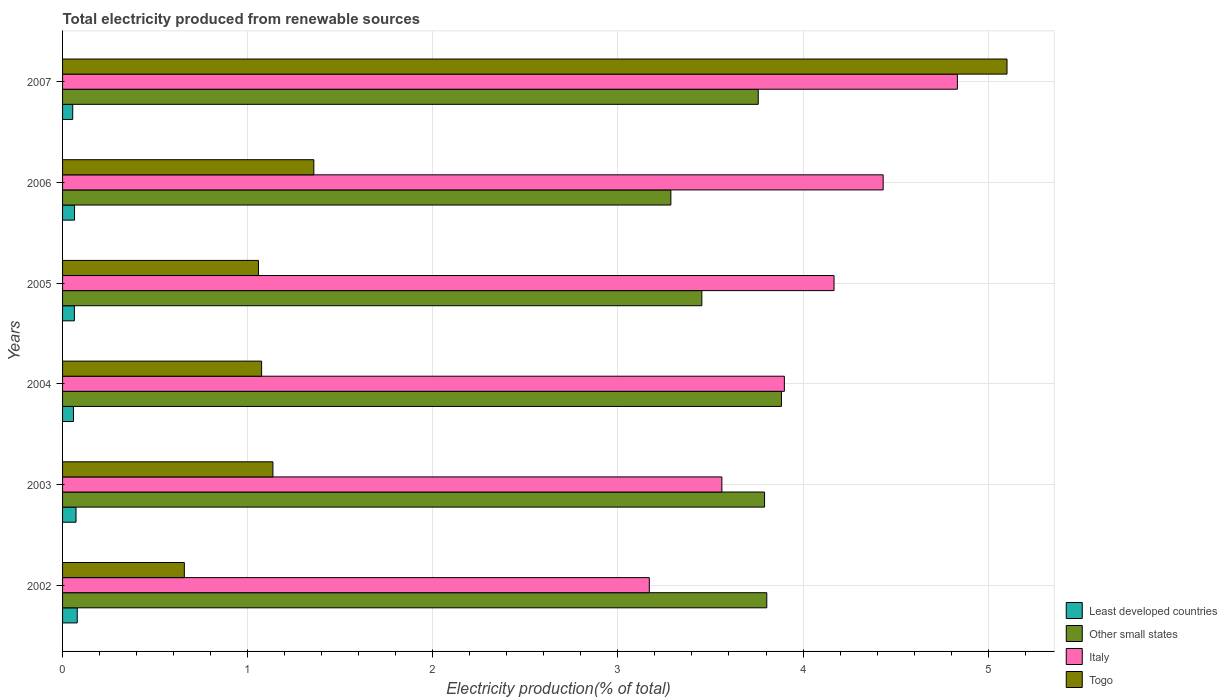How many different coloured bars are there?
Your answer should be very brief. 4. How many groups of bars are there?
Make the answer very short. 6. Are the number of bars per tick equal to the number of legend labels?
Provide a short and direct response. Yes. Are the number of bars on each tick of the Y-axis equal?
Make the answer very short. Yes. How many bars are there on the 1st tick from the bottom?
Keep it short and to the point. 4. What is the label of the 2nd group of bars from the top?
Provide a succinct answer. 2006. What is the total electricity produced in Togo in 2003?
Provide a short and direct response. 1.14. Across all years, what is the maximum total electricity produced in Togo?
Your response must be concise. 5.1. Across all years, what is the minimum total electricity produced in Other small states?
Your answer should be compact. 3.29. In which year was the total electricity produced in Italy maximum?
Make the answer very short. 2007. In which year was the total electricity produced in Togo minimum?
Give a very brief answer. 2002. What is the total total electricity produced in Least developed countries in the graph?
Offer a terse response. 0.39. What is the difference between the total electricity produced in Italy in 2003 and that in 2005?
Provide a short and direct response. -0.61. What is the difference between the total electricity produced in Least developed countries in 2007 and the total electricity produced in Other small states in 2003?
Your response must be concise. -3.74. What is the average total electricity produced in Togo per year?
Keep it short and to the point. 1.73. In the year 2002, what is the difference between the total electricity produced in Italy and total electricity produced in Togo?
Provide a succinct answer. 2.51. In how many years, is the total electricity produced in Least developed countries greater than 1.8 %?
Offer a very short reply. 0. What is the ratio of the total electricity produced in Togo in 2006 to that in 2007?
Offer a terse response. 0.27. Is the total electricity produced in Togo in 2002 less than that in 2007?
Offer a very short reply. Yes. What is the difference between the highest and the second highest total electricity produced in Italy?
Offer a terse response. 0.4. What is the difference between the highest and the lowest total electricity produced in Other small states?
Offer a terse response. 0.6. Is it the case that in every year, the sum of the total electricity produced in Other small states and total electricity produced in Italy is greater than the sum of total electricity produced in Least developed countries and total electricity produced in Togo?
Offer a very short reply. Yes. What does the 4th bar from the top in 2005 represents?
Offer a very short reply. Least developed countries. What does the 2nd bar from the bottom in 2004 represents?
Make the answer very short. Other small states. Is it the case that in every year, the sum of the total electricity produced in Togo and total electricity produced in Italy is greater than the total electricity produced in Least developed countries?
Offer a terse response. Yes. How many bars are there?
Provide a short and direct response. 24. Are all the bars in the graph horizontal?
Your response must be concise. Yes. How many years are there in the graph?
Provide a succinct answer. 6. Are the values on the major ticks of X-axis written in scientific E-notation?
Your answer should be very brief. No. Does the graph contain grids?
Keep it short and to the point. Yes. How many legend labels are there?
Offer a terse response. 4. What is the title of the graph?
Keep it short and to the point. Total electricity produced from renewable sources. Does "Malawi" appear as one of the legend labels in the graph?
Your answer should be compact. No. What is the Electricity production(% of total) in Least developed countries in 2002?
Provide a succinct answer. 0.08. What is the Electricity production(% of total) of Other small states in 2002?
Offer a very short reply. 3.8. What is the Electricity production(% of total) of Italy in 2002?
Provide a short and direct response. 3.17. What is the Electricity production(% of total) of Togo in 2002?
Give a very brief answer. 0.66. What is the Electricity production(% of total) of Least developed countries in 2003?
Offer a terse response. 0.07. What is the Electricity production(% of total) in Other small states in 2003?
Your response must be concise. 3.79. What is the Electricity production(% of total) in Italy in 2003?
Offer a terse response. 3.56. What is the Electricity production(% of total) of Togo in 2003?
Provide a succinct answer. 1.14. What is the Electricity production(% of total) of Least developed countries in 2004?
Your answer should be compact. 0.06. What is the Electricity production(% of total) of Other small states in 2004?
Provide a succinct answer. 3.88. What is the Electricity production(% of total) of Italy in 2004?
Your answer should be very brief. 3.9. What is the Electricity production(% of total) of Togo in 2004?
Provide a succinct answer. 1.08. What is the Electricity production(% of total) of Least developed countries in 2005?
Your answer should be very brief. 0.06. What is the Electricity production(% of total) of Other small states in 2005?
Ensure brevity in your answer.  3.45. What is the Electricity production(% of total) in Italy in 2005?
Provide a succinct answer. 4.17. What is the Electricity production(% of total) in Togo in 2005?
Your response must be concise. 1.06. What is the Electricity production(% of total) in Least developed countries in 2006?
Offer a terse response. 0.06. What is the Electricity production(% of total) of Other small states in 2006?
Keep it short and to the point. 3.29. What is the Electricity production(% of total) of Italy in 2006?
Offer a terse response. 4.43. What is the Electricity production(% of total) in Togo in 2006?
Provide a succinct answer. 1.36. What is the Electricity production(% of total) in Least developed countries in 2007?
Keep it short and to the point. 0.05. What is the Electricity production(% of total) in Other small states in 2007?
Make the answer very short. 3.76. What is the Electricity production(% of total) in Italy in 2007?
Your response must be concise. 4.83. What is the Electricity production(% of total) in Togo in 2007?
Your response must be concise. 5.1. Across all years, what is the maximum Electricity production(% of total) in Least developed countries?
Ensure brevity in your answer.  0.08. Across all years, what is the maximum Electricity production(% of total) of Other small states?
Offer a terse response. 3.88. Across all years, what is the maximum Electricity production(% of total) in Italy?
Offer a terse response. 4.83. Across all years, what is the maximum Electricity production(% of total) in Togo?
Provide a short and direct response. 5.1. Across all years, what is the minimum Electricity production(% of total) of Least developed countries?
Ensure brevity in your answer.  0.05. Across all years, what is the minimum Electricity production(% of total) in Other small states?
Your answer should be compact. 3.29. Across all years, what is the minimum Electricity production(% of total) in Italy?
Your response must be concise. 3.17. Across all years, what is the minimum Electricity production(% of total) of Togo?
Keep it short and to the point. 0.66. What is the total Electricity production(% of total) in Least developed countries in the graph?
Offer a very short reply. 0.39. What is the total Electricity production(% of total) in Other small states in the graph?
Give a very brief answer. 21.98. What is the total Electricity production(% of total) in Italy in the graph?
Your answer should be very brief. 24.07. What is the total Electricity production(% of total) in Togo in the graph?
Keep it short and to the point. 10.39. What is the difference between the Electricity production(% of total) in Least developed countries in 2002 and that in 2003?
Give a very brief answer. 0.01. What is the difference between the Electricity production(% of total) of Other small states in 2002 and that in 2003?
Offer a very short reply. 0.01. What is the difference between the Electricity production(% of total) in Italy in 2002 and that in 2003?
Offer a very short reply. -0.39. What is the difference between the Electricity production(% of total) of Togo in 2002 and that in 2003?
Ensure brevity in your answer.  -0.48. What is the difference between the Electricity production(% of total) in Least developed countries in 2002 and that in 2004?
Make the answer very short. 0.02. What is the difference between the Electricity production(% of total) of Other small states in 2002 and that in 2004?
Provide a short and direct response. -0.08. What is the difference between the Electricity production(% of total) in Italy in 2002 and that in 2004?
Provide a short and direct response. -0.73. What is the difference between the Electricity production(% of total) of Togo in 2002 and that in 2004?
Give a very brief answer. -0.42. What is the difference between the Electricity production(% of total) of Least developed countries in 2002 and that in 2005?
Keep it short and to the point. 0.02. What is the difference between the Electricity production(% of total) of Other small states in 2002 and that in 2005?
Ensure brevity in your answer.  0.35. What is the difference between the Electricity production(% of total) in Italy in 2002 and that in 2005?
Provide a short and direct response. -1. What is the difference between the Electricity production(% of total) of Togo in 2002 and that in 2005?
Your answer should be very brief. -0.4. What is the difference between the Electricity production(% of total) of Least developed countries in 2002 and that in 2006?
Offer a very short reply. 0.01. What is the difference between the Electricity production(% of total) in Other small states in 2002 and that in 2006?
Provide a short and direct response. 0.52. What is the difference between the Electricity production(% of total) of Italy in 2002 and that in 2006?
Make the answer very short. -1.26. What is the difference between the Electricity production(% of total) in Togo in 2002 and that in 2006?
Provide a succinct answer. -0.7. What is the difference between the Electricity production(% of total) in Least developed countries in 2002 and that in 2007?
Your answer should be very brief. 0.02. What is the difference between the Electricity production(% of total) in Other small states in 2002 and that in 2007?
Provide a succinct answer. 0.05. What is the difference between the Electricity production(% of total) in Italy in 2002 and that in 2007?
Provide a succinct answer. -1.66. What is the difference between the Electricity production(% of total) in Togo in 2002 and that in 2007?
Keep it short and to the point. -4.44. What is the difference between the Electricity production(% of total) in Least developed countries in 2003 and that in 2004?
Ensure brevity in your answer.  0.01. What is the difference between the Electricity production(% of total) in Other small states in 2003 and that in 2004?
Provide a short and direct response. -0.09. What is the difference between the Electricity production(% of total) of Italy in 2003 and that in 2004?
Keep it short and to the point. -0.34. What is the difference between the Electricity production(% of total) in Togo in 2003 and that in 2004?
Provide a succinct answer. 0.06. What is the difference between the Electricity production(% of total) of Least developed countries in 2003 and that in 2005?
Your answer should be compact. 0.01. What is the difference between the Electricity production(% of total) in Other small states in 2003 and that in 2005?
Keep it short and to the point. 0.34. What is the difference between the Electricity production(% of total) in Italy in 2003 and that in 2005?
Give a very brief answer. -0.61. What is the difference between the Electricity production(% of total) in Togo in 2003 and that in 2005?
Keep it short and to the point. 0.08. What is the difference between the Electricity production(% of total) of Least developed countries in 2003 and that in 2006?
Provide a succinct answer. 0.01. What is the difference between the Electricity production(% of total) of Other small states in 2003 and that in 2006?
Your response must be concise. 0.51. What is the difference between the Electricity production(% of total) of Italy in 2003 and that in 2006?
Your response must be concise. -0.87. What is the difference between the Electricity production(% of total) in Togo in 2003 and that in 2006?
Your answer should be very brief. -0.22. What is the difference between the Electricity production(% of total) in Least developed countries in 2003 and that in 2007?
Offer a very short reply. 0.02. What is the difference between the Electricity production(% of total) of Other small states in 2003 and that in 2007?
Your answer should be compact. 0.03. What is the difference between the Electricity production(% of total) of Italy in 2003 and that in 2007?
Your answer should be very brief. -1.27. What is the difference between the Electricity production(% of total) of Togo in 2003 and that in 2007?
Your answer should be compact. -3.97. What is the difference between the Electricity production(% of total) of Least developed countries in 2004 and that in 2005?
Keep it short and to the point. -0. What is the difference between the Electricity production(% of total) of Other small states in 2004 and that in 2005?
Keep it short and to the point. 0.43. What is the difference between the Electricity production(% of total) in Italy in 2004 and that in 2005?
Your answer should be compact. -0.27. What is the difference between the Electricity production(% of total) of Togo in 2004 and that in 2005?
Provide a short and direct response. 0.02. What is the difference between the Electricity production(% of total) of Least developed countries in 2004 and that in 2006?
Ensure brevity in your answer.  -0.01. What is the difference between the Electricity production(% of total) in Other small states in 2004 and that in 2006?
Ensure brevity in your answer.  0.6. What is the difference between the Electricity production(% of total) of Italy in 2004 and that in 2006?
Offer a terse response. -0.53. What is the difference between the Electricity production(% of total) of Togo in 2004 and that in 2006?
Your answer should be very brief. -0.28. What is the difference between the Electricity production(% of total) in Least developed countries in 2004 and that in 2007?
Offer a terse response. 0. What is the difference between the Electricity production(% of total) of Other small states in 2004 and that in 2007?
Your answer should be compact. 0.13. What is the difference between the Electricity production(% of total) in Italy in 2004 and that in 2007?
Offer a terse response. -0.93. What is the difference between the Electricity production(% of total) of Togo in 2004 and that in 2007?
Make the answer very short. -4.03. What is the difference between the Electricity production(% of total) of Least developed countries in 2005 and that in 2006?
Provide a short and direct response. -0. What is the difference between the Electricity production(% of total) in Other small states in 2005 and that in 2006?
Keep it short and to the point. 0.17. What is the difference between the Electricity production(% of total) in Italy in 2005 and that in 2006?
Provide a succinct answer. -0.27. What is the difference between the Electricity production(% of total) in Togo in 2005 and that in 2006?
Make the answer very short. -0.3. What is the difference between the Electricity production(% of total) in Least developed countries in 2005 and that in 2007?
Give a very brief answer. 0.01. What is the difference between the Electricity production(% of total) of Other small states in 2005 and that in 2007?
Offer a terse response. -0.3. What is the difference between the Electricity production(% of total) in Italy in 2005 and that in 2007?
Your answer should be compact. -0.67. What is the difference between the Electricity production(% of total) in Togo in 2005 and that in 2007?
Keep it short and to the point. -4.04. What is the difference between the Electricity production(% of total) of Least developed countries in 2006 and that in 2007?
Your answer should be compact. 0.01. What is the difference between the Electricity production(% of total) in Other small states in 2006 and that in 2007?
Offer a terse response. -0.47. What is the difference between the Electricity production(% of total) in Italy in 2006 and that in 2007?
Give a very brief answer. -0.4. What is the difference between the Electricity production(% of total) in Togo in 2006 and that in 2007?
Your answer should be compact. -3.74. What is the difference between the Electricity production(% of total) in Least developed countries in 2002 and the Electricity production(% of total) in Other small states in 2003?
Make the answer very short. -3.71. What is the difference between the Electricity production(% of total) in Least developed countries in 2002 and the Electricity production(% of total) in Italy in 2003?
Provide a succinct answer. -3.48. What is the difference between the Electricity production(% of total) in Least developed countries in 2002 and the Electricity production(% of total) in Togo in 2003?
Make the answer very short. -1.06. What is the difference between the Electricity production(% of total) of Other small states in 2002 and the Electricity production(% of total) of Italy in 2003?
Offer a terse response. 0.24. What is the difference between the Electricity production(% of total) in Other small states in 2002 and the Electricity production(% of total) in Togo in 2003?
Give a very brief answer. 2.67. What is the difference between the Electricity production(% of total) in Italy in 2002 and the Electricity production(% of total) in Togo in 2003?
Your answer should be very brief. 2.03. What is the difference between the Electricity production(% of total) of Least developed countries in 2002 and the Electricity production(% of total) of Other small states in 2004?
Provide a short and direct response. -3.8. What is the difference between the Electricity production(% of total) of Least developed countries in 2002 and the Electricity production(% of total) of Italy in 2004?
Ensure brevity in your answer.  -3.82. What is the difference between the Electricity production(% of total) in Least developed countries in 2002 and the Electricity production(% of total) in Togo in 2004?
Provide a succinct answer. -1. What is the difference between the Electricity production(% of total) in Other small states in 2002 and the Electricity production(% of total) in Italy in 2004?
Provide a short and direct response. -0.1. What is the difference between the Electricity production(% of total) of Other small states in 2002 and the Electricity production(% of total) of Togo in 2004?
Give a very brief answer. 2.73. What is the difference between the Electricity production(% of total) in Italy in 2002 and the Electricity production(% of total) in Togo in 2004?
Provide a short and direct response. 2.09. What is the difference between the Electricity production(% of total) in Least developed countries in 2002 and the Electricity production(% of total) in Other small states in 2005?
Keep it short and to the point. -3.37. What is the difference between the Electricity production(% of total) of Least developed countries in 2002 and the Electricity production(% of total) of Italy in 2005?
Your response must be concise. -4.09. What is the difference between the Electricity production(% of total) in Least developed countries in 2002 and the Electricity production(% of total) in Togo in 2005?
Offer a terse response. -0.98. What is the difference between the Electricity production(% of total) of Other small states in 2002 and the Electricity production(% of total) of Italy in 2005?
Your answer should be very brief. -0.36. What is the difference between the Electricity production(% of total) in Other small states in 2002 and the Electricity production(% of total) in Togo in 2005?
Keep it short and to the point. 2.75. What is the difference between the Electricity production(% of total) in Italy in 2002 and the Electricity production(% of total) in Togo in 2005?
Your answer should be very brief. 2.11. What is the difference between the Electricity production(% of total) in Least developed countries in 2002 and the Electricity production(% of total) in Other small states in 2006?
Keep it short and to the point. -3.21. What is the difference between the Electricity production(% of total) of Least developed countries in 2002 and the Electricity production(% of total) of Italy in 2006?
Your response must be concise. -4.35. What is the difference between the Electricity production(% of total) of Least developed countries in 2002 and the Electricity production(% of total) of Togo in 2006?
Your answer should be very brief. -1.28. What is the difference between the Electricity production(% of total) of Other small states in 2002 and the Electricity production(% of total) of Italy in 2006?
Give a very brief answer. -0.63. What is the difference between the Electricity production(% of total) of Other small states in 2002 and the Electricity production(% of total) of Togo in 2006?
Your response must be concise. 2.45. What is the difference between the Electricity production(% of total) in Italy in 2002 and the Electricity production(% of total) in Togo in 2006?
Give a very brief answer. 1.81. What is the difference between the Electricity production(% of total) in Least developed countries in 2002 and the Electricity production(% of total) in Other small states in 2007?
Your response must be concise. -3.68. What is the difference between the Electricity production(% of total) in Least developed countries in 2002 and the Electricity production(% of total) in Italy in 2007?
Offer a very short reply. -4.75. What is the difference between the Electricity production(% of total) in Least developed countries in 2002 and the Electricity production(% of total) in Togo in 2007?
Offer a very short reply. -5.02. What is the difference between the Electricity production(% of total) in Other small states in 2002 and the Electricity production(% of total) in Italy in 2007?
Keep it short and to the point. -1.03. What is the difference between the Electricity production(% of total) in Other small states in 2002 and the Electricity production(% of total) in Togo in 2007?
Your response must be concise. -1.3. What is the difference between the Electricity production(% of total) in Italy in 2002 and the Electricity production(% of total) in Togo in 2007?
Provide a succinct answer. -1.93. What is the difference between the Electricity production(% of total) of Least developed countries in 2003 and the Electricity production(% of total) of Other small states in 2004?
Keep it short and to the point. -3.81. What is the difference between the Electricity production(% of total) of Least developed countries in 2003 and the Electricity production(% of total) of Italy in 2004?
Keep it short and to the point. -3.83. What is the difference between the Electricity production(% of total) of Least developed countries in 2003 and the Electricity production(% of total) of Togo in 2004?
Provide a short and direct response. -1. What is the difference between the Electricity production(% of total) in Other small states in 2003 and the Electricity production(% of total) in Italy in 2004?
Give a very brief answer. -0.11. What is the difference between the Electricity production(% of total) in Other small states in 2003 and the Electricity production(% of total) in Togo in 2004?
Your response must be concise. 2.72. What is the difference between the Electricity production(% of total) of Italy in 2003 and the Electricity production(% of total) of Togo in 2004?
Your answer should be compact. 2.49. What is the difference between the Electricity production(% of total) of Least developed countries in 2003 and the Electricity production(% of total) of Other small states in 2005?
Provide a succinct answer. -3.38. What is the difference between the Electricity production(% of total) in Least developed countries in 2003 and the Electricity production(% of total) in Italy in 2005?
Your answer should be very brief. -4.09. What is the difference between the Electricity production(% of total) of Least developed countries in 2003 and the Electricity production(% of total) of Togo in 2005?
Ensure brevity in your answer.  -0.99. What is the difference between the Electricity production(% of total) of Other small states in 2003 and the Electricity production(% of total) of Italy in 2005?
Keep it short and to the point. -0.38. What is the difference between the Electricity production(% of total) of Other small states in 2003 and the Electricity production(% of total) of Togo in 2005?
Your answer should be very brief. 2.73. What is the difference between the Electricity production(% of total) of Italy in 2003 and the Electricity production(% of total) of Togo in 2005?
Your answer should be very brief. 2.5. What is the difference between the Electricity production(% of total) in Least developed countries in 2003 and the Electricity production(% of total) in Other small states in 2006?
Ensure brevity in your answer.  -3.21. What is the difference between the Electricity production(% of total) in Least developed countries in 2003 and the Electricity production(% of total) in Italy in 2006?
Provide a succinct answer. -4.36. What is the difference between the Electricity production(% of total) in Least developed countries in 2003 and the Electricity production(% of total) in Togo in 2006?
Give a very brief answer. -1.28. What is the difference between the Electricity production(% of total) in Other small states in 2003 and the Electricity production(% of total) in Italy in 2006?
Give a very brief answer. -0.64. What is the difference between the Electricity production(% of total) in Other small states in 2003 and the Electricity production(% of total) in Togo in 2006?
Offer a very short reply. 2.43. What is the difference between the Electricity production(% of total) of Italy in 2003 and the Electricity production(% of total) of Togo in 2006?
Ensure brevity in your answer.  2.2. What is the difference between the Electricity production(% of total) in Least developed countries in 2003 and the Electricity production(% of total) in Other small states in 2007?
Keep it short and to the point. -3.69. What is the difference between the Electricity production(% of total) of Least developed countries in 2003 and the Electricity production(% of total) of Italy in 2007?
Ensure brevity in your answer.  -4.76. What is the difference between the Electricity production(% of total) of Least developed countries in 2003 and the Electricity production(% of total) of Togo in 2007?
Provide a succinct answer. -5.03. What is the difference between the Electricity production(% of total) in Other small states in 2003 and the Electricity production(% of total) in Italy in 2007?
Provide a short and direct response. -1.04. What is the difference between the Electricity production(% of total) of Other small states in 2003 and the Electricity production(% of total) of Togo in 2007?
Ensure brevity in your answer.  -1.31. What is the difference between the Electricity production(% of total) of Italy in 2003 and the Electricity production(% of total) of Togo in 2007?
Make the answer very short. -1.54. What is the difference between the Electricity production(% of total) in Least developed countries in 2004 and the Electricity production(% of total) in Other small states in 2005?
Ensure brevity in your answer.  -3.39. What is the difference between the Electricity production(% of total) in Least developed countries in 2004 and the Electricity production(% of total) in Italy in 2005?
Keep it short and to the point. -4.11. What is the difference between the Electricity production(% of total) in Least developed countries in 2004 and the Electricity production(% of total) in Togo in 2005?
Your answer should be very brief. -1. What is the difference between the Electricity production(% of total) of Other small states in 2004 and the Electricity production(% of total) of Italy in 2005?
Give a very brief answer. -0.28. What is the difference between the Electricity production(% of total) of Other small states in 2004 and the Electricity production(% of total) of Togo in 2005?
Keep it short and to the point. 2.83. What is the difference between the Electricity production(% of total) in Italy in 2004 and the Electricity production(% of total) in Togo in 2005?
Provide a succinct answer. 2.84. What is the difference between the Electricity production(% of total) in Least developed countries in 2004 and the Electricity production(% of total) in Other small states in 2006?
Your answer should be compact. -3.23. What is the difference between the Electricity production(% of total) of Least developed countries in 2004 and the Electricity production(% of total) of Italy in 2006?
Provide a succinct answer. -4.37. What is the difference between the Electricity production(% of total) in Least developed countries in 2004 and the Electricity production(% of total) in Togo in 2006?
Offer a terse response. -1.3. What is the difference between the Electricity production(% of total) in Other small states in 2004 and the Electricity production(% of total) in Italy in 2006?
Make the answer very short. -0.55. What is the difference between the Electricity production(% of total) in Other small states in 2004 and the Electricity production(% of total) in Togo in 2006?
Provide a succinct answer. 2.53. What is the difference between the Electricity production(% of total) of Italy in 2004 and the Electricity production(% of total) of Togo in 2006?
Your answer should be very brief. 2.54. What is the difference between the Electricity production(% of total) of Least developed countries in 2004 and the Electricity production(% of total) of Other small states in 2007?
Make the answer very short. -3.7. What is the difference between the Electricity production(% of total) in Least developed countries in 2004 and the Electricity production(% of total) in Italy in 2007?
Your answer should be very brief. -4.78. What is the difference between the Electricity production(% of total) of Least developed countries in 2004 and the Electricity production(% of total) of Togo in 2007?
Offer a very short reply. -5.04. What is the difference between the Electricity production(% of total) of Other small states in 2004 and the Electricity production(% of total) of Italy in 2007?
Provide a short and direct response. -0.95. What is the difference between the Electricity production(% of total) in Other small states in 2004 and the Electricity production(% of total) in Togo in 2007?
Give a very brief answer. -1.22. What is the difference between the Electricity production(% of total) in Italy in 2004 and the Electricity production(% of total) in Togo in 2007?
Provide a succinct answer. -1.2. What is the difference between the Electricity production(% of total) in Least developed countries in 2005 and the Electricity production(% of total) in Other small states in 2006?
Offer a very short reply. -3.22. What is the difference between the Electricity production(% of total) in Least developed countries in 2005 and the Electricity production(% of total) in Italy in 2006?
Your answer should be compact. -4.37. What is the difference between the Electricity production(% of total) in Least developed countries in 2005 and the Electricity production(% of total) in Togo in 2006?
Provide a succinct answer. -1.29. What is the difference between the Electricity production(% of total) of Other small states in 2005 and the Electricity production(% of total) of Italy in 2006?
Keep it short and to the point. -0.98. What is the difference between the Electricity production(% of total) of Other small states in 2005 and the Electricity production(% of total) of Togo in 2006?
Keep it short and to the point. 2.1. What is the difference between the Electricity production(% of total) of Italy in 2005 and the Electricity production(% of total) of Togo in 2006?
Your response must be concise. 2.81. What is the difference between the Electricity production(% of total) of Least developed countries in 2005 and the Electricity production(% of total) of Other small states in 2007?
Offer a very short reply. -3.69. What is the difference between the Electricity production(% of total) of Least developed countries in 2005 and the Electricity production(% of total) of Italy in 2007?
Offer a very short reply. -4.77. What is the difference between the Electricity production(% of total) of Least developed countries in 2005 and the Electricity production(% of total) of Togo in 2007?
Make the answer very short. -5.04. What is the difference between the Electricity production(% of total) in Other small states in 2005 and the Electricity production(% of total) in Italy in 2007?
Provide a succinct answer. -1.38. What is the difference between the Electricity production(% of total) of Other small states in 2005 and the Electricity production(% of total) of Togo in 2007?
Offer a terse response. -1.65. What is the difference between the Electricity production(% of total) of Italy in 2005 and the Electricity production(% of total) of Togo in 2007?
Your response must be concise. -0.93. What is the difference between the Electricity production(% of total) of Least developed countries in 2006 and the Electricity production(% of total) of Other small states in 2007?
Your answer should be compact. -3.69. What is the difference between the Electricity production(% of total) of Least developed countries in 2006 and the Electricity production(% of total) of Italy in 2007?
Provide a succinct answer. -4.77. What is the difference between the Electricity production(% of total) in Least developed countries in 2006 and the Electricity production(% of total) in Togo in 2007?
Provide a short and direct response. -5.04. What is the difference between the Electricity production(% of total) in Other small states in 2006 and the Electricity production(% of total) in Italy in 2007?
Provide a short and direct response. -1.55. What is the difference between the Electricity production(% of total) of Other small states in 2006 and the Electricity production(% of total) of Togo in 2007?
Ensure brevity in your answer.  -1.82. What is the difference between the Electricity production(% of total) in Italy in 2006 and the Electricity production(% of total) in Togo in 2007?
Your answer should be compact. -0.67. What is the average Electricity production(% of total) of Least developed countries per year?
Your response must be concise. 0.07. What is the average Electricity production(% of total) in Other small states per year?
Your answer should be very brief. 3.66. What is the average Electricity production(% of total) in Italy per year?
Your response must be concise. 4.01. What is the average Electricity production(% of total) in Togo per year?
Offer a terse response. 1.73. In the year 2002, what is the difference between the Electricity production(% of total) in Least developed countries and Electricity production(% of total) in Other small states?
Provide a short and direct response. -3.73. In the year 2002, what is the difference between the Electricity production(% of total) of Least developed countries and Electricity production(% of total) of Italy?
Your answer should be compact. -3.09. In the year 2002, what is the difference between the Electricity production(% of total) of Least developed countries and Electricity production(% of total) of Togo?
Provide a succinct answer. -0.58. In the year 2002, what is the difference between the Electricity production(% of total) in Other small states and Electricity production(% of total) in Italy?
Ensure brevity in your answer.  0.63. In the year 2002, what is the difference between the Electricity production(% of total) of Other small states and Electricity production(% of total) of Togo?
Your response must be concise. 3.15. In the year 2002, what is the difference between the Electricity production(% of total) of Italy and Electricity production(% of total) of Togo?
Provide a short and direct response. 2.51. In the year 2003, what is the difference between the Electricity production(% of total) in Least developed countries and Electricity production(% of total) in Other small states?
Offer a terse response. -3.72. In the year 2003, what is the difference between the Electricity production(% of total) of Least developed countries and Electricity production(% of total) of Italy?
Provide a succinct answer. -3.49. In the year 2003, what is the difference between the Electricity production(% of total) in Least developed countries and Electricity production(% of total) in Togo?
Make the answer very short. -1.06. In the year 2003, what is the difference between the Electricity production(% of total) of Other small states and Electricity production(% of total) of Italy?
Your answer should be very brief. 0.23. In the year 2003, what is the difference between the Electricity production(% of total) in Other small states and Electricity production(% of total) in Togo?
Your answer should be very brief. 2.66. In the year 2003, what is the difference between the Electricity production(% of total) of Italy and Electricity production(% of total) of Togo?
Your answer should be compact. 2.43. In the year 2004, what is the difference between the Electricity production(% of total) of Least developed countries and Electricity production(% of total) of Other small states?
Ensure brevity in your answer.  -3.82. In the year 2004, what is the difference between the Electricity production(% of total) of Least developed countries and Electricity production(% of total) of Italy?
Provide a short and direct response. -3.84. In the year 2004, what is the difference between the Electricity production(% of total) in Least developed countries and Electricity production(% of total) in Togo?
Your answer should be compact. -1.02. In the year 2004, what is the difference between the Electricity production(% of total) in Other small states and Electricity production(% of total) in Italy?
Your answer should be very brief. -0.02. In the year 2004, what is the difference between the Electricity production(% of total) in Other small states and Electricity production(% of total) in Togo?
Your response must be concise. 2.81. In the year 2004, what is the difference between the Electricity production(% of total) in Italy and Electricity production(% of total) in Togo?
Provide a succinct answer. 2.82. In the year 2005, what is the difference between the Electricity production(% of total) in Least developed countries and Electricity production(% of total) in Other small states?
Make the answer very short. -3.39. In the year 2005, what is the difference between the Electricity production(% of total) in Least developed countries and Electricity production(% of total) in Italy?
Keep it short and to the point. -4.1. In the year 2005, what is the difference between the Electricity production(% of total) in Least developed countries and Electricity production(% of total) in Togo?
Keep it short and to the point. -0.99. In the year 2005, what is the difference between the Electricity production(% of total) of Other small states and Electricity production(% of total) of Italy?
Your answer should be very brief. -0.71. In the year 2005, what is the difference between the Electricity production(% of total) of Other small states and Electricity production(% of total) of Togo?
Your answer should be compact. 2.4. In the year 2005, what is the difference between the Electricity production(% of total) in Italy and Electricity production(% of total) in Togo?
Ensure brevity in your answer.  3.11. In the year 2006, what is the difference between the Electricity production(% of total) of Least developed countries and Electricity production(% of total) of Other small states?
Your answer should be very brief. -3.22. In the year 2006, what is the difference between the Electricity production(% of total) in Least developed countries and Electricity production(% of total) in Italy?
Give a very brief answer. -4.37. In the year 2006, what is the difference between the Electricity production(% of total) in Least developed countries and Electricity production(% of total) in Togo?
Your answer should be compact. -1.29. In the year 2006, what is the difference between the Electricity production(% of total) of Other small states and Electricity production(% of total) of Italy?
Offer a very short reply. -1.15. In the year 2006, what is the difference between the Electricity production(% of total) of Other small states and Electricity production(% of total) of Togo?
Make the answer very short. 1.93. In the year 2006, what is the difference between the Electricity production(% of total) of Italy and Electricity production(% of total) of Togo?
Make the answer very short. 3.08. In the year 2007, what is the difference between the Electricity production(% of total) in Least developed countries and Electricity production(% of total) in Other small states?
Offer a terse response. -3.7. In the year 2007, what is the difference between the Electricity production(% of total) of Least developed countries and Electricity production(% of total) of Italy?
Offer a very short reply. -4.78. In the year 2007, what is the difference between the Electricity production(% of total) of Least developed countries and Electricity production(% of total) of Togo?
Your response must be concise. -5.05. In the year 2007, what is the difference between the Electricity production(% of total) in Other small states and Electricity production(% of total) in Italy?
Provide a succinct answer. -1.08. In the year 2007, what is the difference between the Electricity production(% of total) of Other small states and Electricity production(% of total) of Togo?
Provide a succinct answer. -1.34. In the year 2007, what is the difference between the Electricity production(% of total) in Italy and Electricity production(% of total) in Togo?
Make the answer very short. -0.27. What is the ratio of the Electricity production(% of total) in Least developed countries in 2002 to that in 2003?
Your answer should be compact. 1.09. What is the ratio of the Electricity production(% of total) in Other small states in 2002 to that in 2003?
Your answer should be compact. 1. What is the ratio of the Electricity production(% of total) in Italy in 2002 to that in 2003?
Provide a succinct answer. 0.89. What is the ratio of the Electricity production(% of total) in Togo in 2002 to that in 2003?
Make the answer very short. 0.58. What is the ratio of the Electricity production(% of total) of Least developed countries in 2002 to that in 2004?
Ensure brevity in your answer.  1.35. What is the ratio of the Electricity production(% of total) in Other small states in 2002 to that in 2004?
Your answer should be compact. 0.98. What is the ratio of the Electricity production(% of total) in Italy in 2002 to that in 2004?
Make the answer very short. 0.81. What is the ratio of the Electricity production(% of total) of Togo in 2002 to that in 2004?
Your response must be concise. 0.61. What is the ratio of the Electricity production(% of total) in Least developed countries in 2002 to that in 2005?
Offer a very short reply. 1.24. What is the ratio of the Electricity production(% of total) in Other small states in 2002 to that in 2005?
Give a very brief answer. 1.1. What is the ratio of the Electricity production(% of total) of Italy in 2002 to that in 2005?
Make the answer very short. 0.76. What is the ratio of the Electricity production(% of total) of Togo in 2002 to that in 2005?
Ensure brevity in your answer.  0.62. What is the ratio of the Electricity production(% of total) of Least developed countries in 2002 to that in 2006?
Provide a short and direct response. 1.23. What is the ratio of the Electricity production(% of total) in Other small states in 2002 to that in 2006?
Keep it short and to the point. 1.16. What is the ratio of the Electricity production(% of total) in Italy in 2002 to that in 2006?
Provide a short and direct response. 0.71. What is the ratio of the Electricity production(% of total) of Togo in 2002 to that in 2006?
Make the answer very short. 0.48. What is the ratio of the Electricity production(% of total) of Least developed countries in 2002 to that in 2007?
Offer a very short reply. 1.44. What is the ratio of the Electricity production(% of total) of Other small states in 2002 to that in 2007?
Your answer should be very brief. 1.01. What is the ratio of the Electricity production(% of total) of Italy in 2002 to that in 2007?
Your answer should be very brief. 0.66. What is the ratio of the Electricity production(% of total) in Togo in 2002 to that in 2007?
Give a very brief answer. 0.13. What is the ratio of the Electricity production(% of total) in Least developed countries in 2003 to that in 2004?
Your answer should be compact. 1.24. What is the ratio of the Electricity production(% of total) in Other small states in 2003 to that in 2004?
Offer a very short reply. 0.98. What is the ratio of the Electricity production(% of total) of Italy in 2003 to that in 2004?
Keep it short and to the point. 0.91. What is the ratio of the Electricity production(% of total) of Togo in 2003 to that in 2004?
Your response must be concise. 1.06. What is the ratio of the Electricity production(% of total) in Least developed countries in 2003 to that in 2005?
Ensure brevity in your answer.  1.14. What is the ratio of the Electricity production(% of total) of Other small states in 2003 to that in 2005?
Your answer should be compact. 1.1. What is the ratio of the Electricity production(% of total) in Italy in 2003 to that in 2005?
Provide a short and direct response. 0.85. What is the ratio of the Electricity production(% of total) in Togo in 2003 to that in 2005?
Make the answer very short. 1.07. What is the ratio of the Electricity production(% of total) of Least developed countries in 2003 to that in 2006?
Provide a succinct answer. 1.13. What is the ratio of the Electricity production(% of total) of Other small states in 2003 to that in 2006?
Give a very brief answer. 1.15. What is the ratio of the Electricity production(% of total) of Italy in 2003 to that in 2006?
Provide a succinct answer. 0.8. What is the ratio of the Electricity production(% of total) in Togo in 2003 to that in 2006?
Your answer should be compact. 0.84. What is the ratio of the Electricity production(% of total) in Least developed countries in 2003 to that in 2007?
Make the answer very short. 1.33. What is the ratio of the Electricity production(% of total) of Other small states in 2003 to that in 2007?
Offer a very short reply. 1.01. What is the ratio of the Electricity production(% of total) of Italy in 2003 to that in 2007?
Ensure brevity in your answer.  0.74. What is the ratio of the Electricity production(% of total) in Togo in 2003 to that in 2007?
Ensure brevity in your answer.  0.22. What is the ratio of the Electricity production(% of total) of Least developed countries in 2004 to that in 2005?
Provide a short and direct response. 0.92. What is the ratio of the Electricity production(% of total) in Other small states in 2004 to that in 2005?
Give a very brief answer. 1.12. What is the ratio of the Electricity production(% of total) of Italy in 2004 to that in 2005?
Keep it short and to the point. 0.94. What is the ratio of the Electricity production(% of total) in Togo in 2004 to that in 2005?
Offer a terse response. 1.02. What is the ratio of the Electricity production(% of total) of Least developed countries in 2004 to that in 2006?
Make the answer very short. 0.91. What is the ratio of the Electricity production(% of total) of Other small states in 2004 to that in 2006?
Offer a terse response. 1.18. What is the ratio of the Electricity production(% of total) in Italy in 2004 to that in 2006?
Give a very brief answer. 0.88. What is the ratio of the Electricity production(% of total) of Togo in 2004 to that in 2006?
Your response must be concise. 0.79. What is the ratio of the Electricity production(% of total) in Least developed countries in 2004 to that in 2007?
Your response must be concise. 1.07. What is the ratio of the Electricity production(% of total) in Other small states in 2004 to that in 2007?
Provide a short and direct response. 1.03. What is the ratio of the Electricity production(% of total) of Italy in 2004 to that in 2007?
Keep it short and to the point. 0.81. What is the ratio of the Electricity production(% of total) of Togo in 2004 to that in 2007?
Your answer should be very brief. 0.21. What is the ratio of the Electricity production(% of total) in Least developed countries in 2005 to that in 2006?
Your answer should be very brief. 0.99. What is the ratio of the Electricity production(% of total) of Other small states in 2005 to that in 2006?
Keep it short and to the point. 1.05. What is the ratio of the Electricity production(% of total) of Italy in 2005 to that in 2006?
Give a very brief answer. 0.94. What is the ratio of the Electricity production(% of total) of Togo in 2005 to that in 2006?
Keep it short and to the point. 0.78. What is the ratio of the Electricity production(% of total) of Least developed countries in 2005 to that in 2007?
Provide a succinct answer. 1.16. What is the ratio of the Electricity production(% of total) of Other small states in 2005 to that in 2007?
Keep it short and to the point. 0.92. What is the ratio of the Electricity production(% of total) of Italy in 2005 to that in 2007?
Keep it short and to the point. 0.86. What is the ratio of the Electricity production(% of total) of Togo in 2005 to that in 2007?
Keep it short and to the point. 0.21. What is the ratio of the Electricity production(% of total) of Least developed countries in 2006 to that in 2007?
Provide a short and direct response. 1.18. What is the ratio of the Electricity production(% of total) of Other small states in 2006 to that in 2007?
Ensure brevity in your answer.  0.87. What is the ratio of the Electricity production(% of total) of Italy in 2006 to that in 2007?
Offer a very short reply. 0.92. What is the ratio of the Electricity production(% of total) of Togo in 2006 to that in 2007?
Your answer should be very brief. 0.27. What is the difference between the highest and the second highest Electricity production(% of total) of Least developed countries?
Your response must be concise. 0.01. What is the difference between the highest and the second highest Electricity production(% of total) of Other small states?
Ensure brevity in your answer.  0.08. What is the difference between the highest and the second highest Electricity production(% of total) in Italy?
Make the answer very short. 0.4. What is the difference between the highest and the second highest Electricity production(% of total) of Togo?
Your answer should be very brief. 3.74. What is the difference between the highest and the lowest Electricity production(% of total) in Least developed countries?
Give a very brief answer. 0.02. What is the difference between the highest and the lowest Electricity production(% of total) of Other small states?
Ensure brevity in your answer.  0.6. What is the difference between the highest and the lowest Electricity production(% of total) of Italy?
Your answer should be compact. 1.66. What is the difference between the highest and the lowest Electricity production(% of total) in Togo?
Your response must be concise. 4.44. 